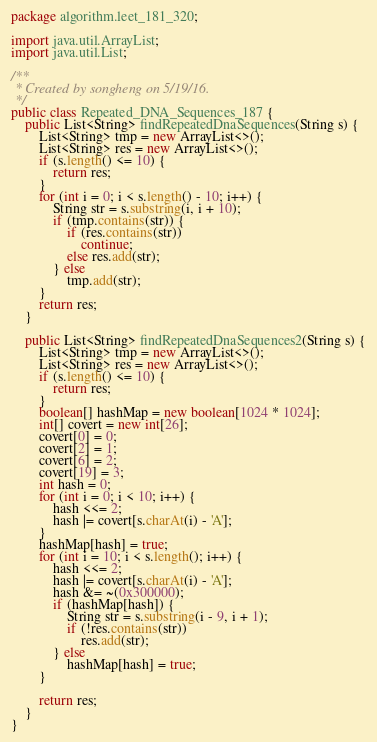<code> <loc_0><loc_0><loc_500><loc_500><_Java_>package algorithm.leet_181_320;

import java.util.ArrayList;
import java.util.List;

/**
 * Created by songheng on 5/19/16.
 */
public class Repeated_DNA_Sequences_187 {
    public List<String> findRepeatedDnaSequences(String s) {
        List<String> tmp = new ArrayList<>();
        List<String> res = new ArrayList<>();
        if (s.length() <= 10) {
            return res;
        }
        for (int i = 0; i < s.length() - 10; i++) {
            String str = s.substring(i, i + 10);
            if (tmp.contains(str)) {
                if (res.contains(str))
                    continue;
                else res.add(str);
            } else
                tmp.add(str);
        }
        return res;
    }

    public List<String> findRepeatedDnaSequences2(String s) {
        List<String> tmp = new ArrayList<>();
        List<String> res = new ArrayList<>();
        if (s.length() <= 10) {
            return res;
        }
        boolean[] hashMap = new boolean[1024 * 1024];
        int[] covert = new int[26];
        covert[0] = 0;
        covert[2] = 1;
        covert[6] = 2;
        covert[19] = 3;
        int hash = 0;
        for (int i = 0; i < 10; i++) {
            hash <<= 2;
            hash |= covert[s.charAt(i) - 'A'];
        }
        hashMap[hash] = true;
        for (int i = 10; i < s.length(); i++) {
            hash <<= 2;
            hash |= covert[s.charAt(i) - 'A'];
            hash &= ~(0x300000);
            if (hashMap[hash]) {
                String str = s.substring(i - 9, i + 1);
                if (!res.contains(str))
                    res.add(str);
            } else
                hashMap[hash] = true;
        }

        return res;
    }
}
</code> 